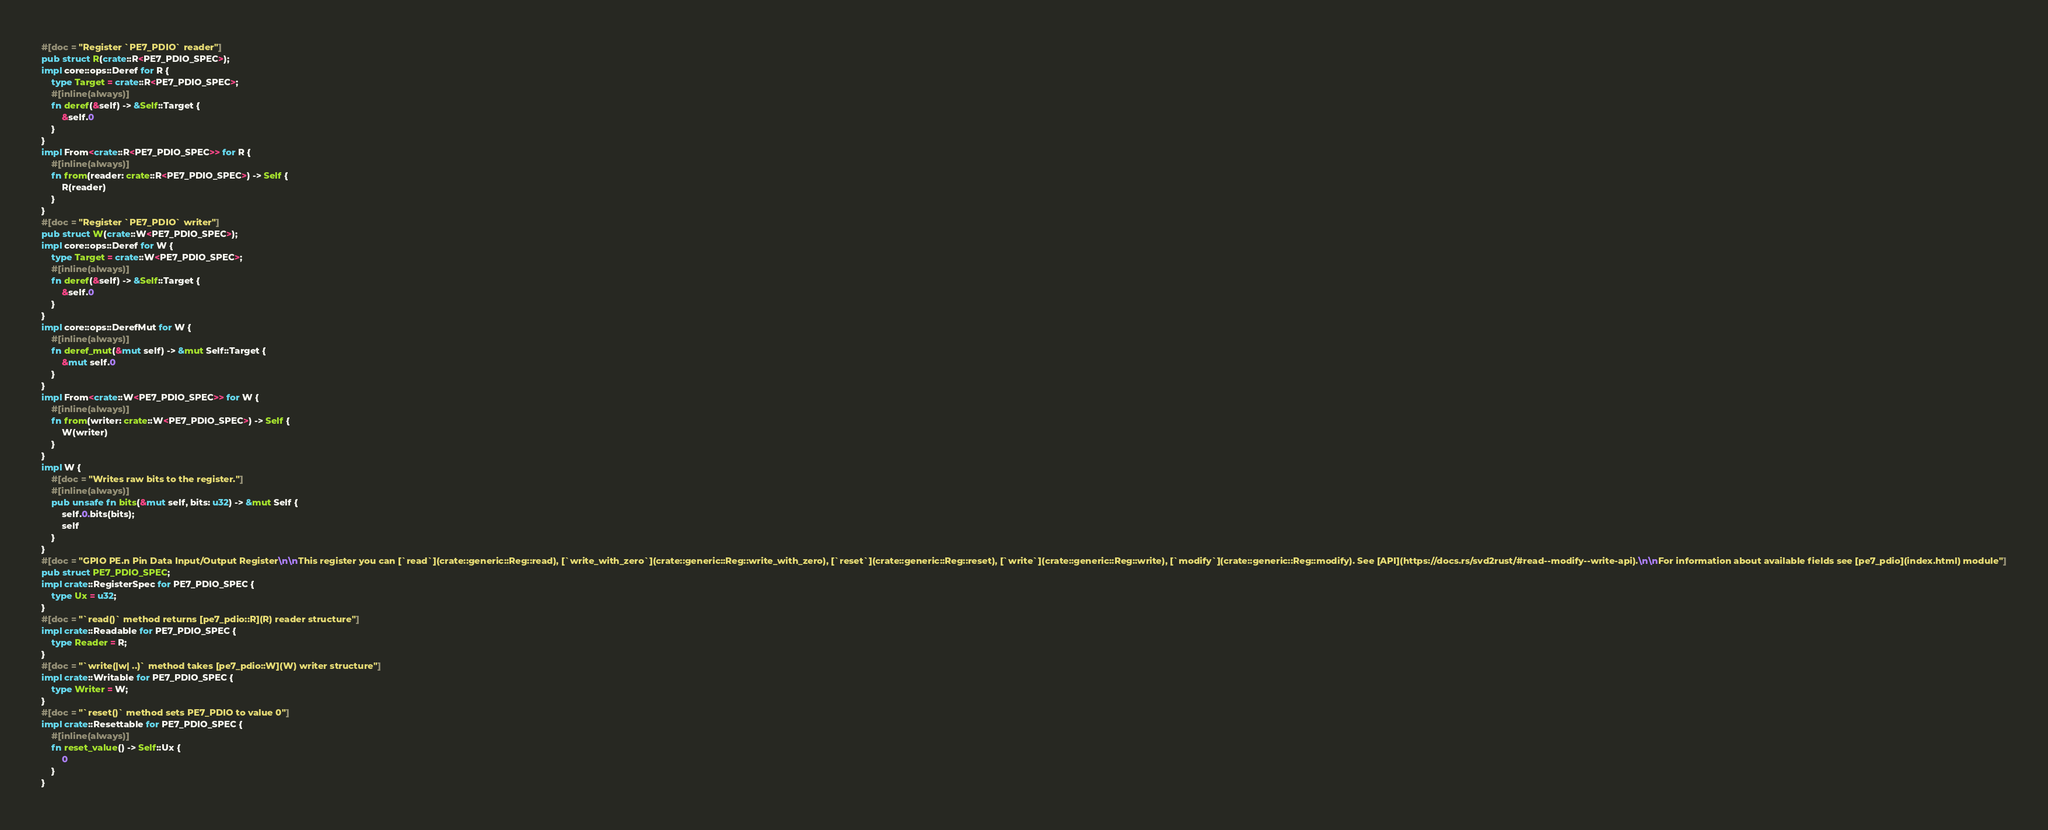Convert code to text. <code><loc_0><loc_0><loc_500><loc_500><_Rust_>#[doc = "Register `PE7_PDIO` reader"]
pub struct R(crate::R<PE7_PDIO_SPEC>);
impl core::ops::Deref for R {
    type Target = crate::R<PE7_PDIO_SPEC>;
    #[inline(always)]
    fn deref(&self) -> &Self::Target {
        &self.0
    }
}
impl From<crate::R<PE7_PDIO_SPEC>> for R {
    #[inline(always)]
    fn from(reader: crate::R<PE7_PDIO_SPEC>) -> Self {
        R(reader)
    }
}
#[doc = "Register `PE7_PDIO` writer"]
pub struct W(crate::W<PE7_PDIO_SPEC>);
impl core::ops::Deref for W {
    type Target = crate::W<PE7_PDIO_SPEC>;
    #[inline(always)]
    fn deref(&self) -> &Self::Target {
        &self.0
    }
}
impl core::ops::DerefMut for W {
    #[inline(always)]
    fn deref_mut(&mut self) -> &mut Self::Target {
        &mut self.0
    }
}
impl From<crate::W<PE7_PDIO_SPEC>> for W {
    #[inline(always)]
    fn from(writer: crate::W<PE7_PDIO_SPEC>) -> Self {
        W(writer)
    }
}
impl W {
    #[doc = "Writes raw bits to the register."]
    #[inline(always)]
    pub unsafe fn bits(&mut self, bits: u32) -> &mut Self {
        self.0.bits(bits);
        self
    }
}
#[doc = "GPIO PE.n Pin Data Input/Output Register\n\nThis register you can [`read`](crate::generic::Reg::read), [`write_with_zero`](crate::generic::Reg::write_with_zero), [`reset`](crate::generic::Reg::reset), [`write`](crate::generic::Reg::write), [`modify`](crate::generic::Reg::modify). See [API](https://docs.rs/svd2rust/#read--modify--write-api).\n\nFor information about available fields see [pe7_pdio](index.html) module"]
pub struct PE7_PDIO_SPEC;
impl crate::RegisterSpec for PE7_PDIO_SPEC {
    type Ux = u32;
}
#[doc = "`read()` method returns [pe7_pdio::R](R) reader structure"]
impl crate::Readable for PE7_PDIO_SPEC {
    type Reader = R;
}
#[doc = "`write(|w| ..)` method takes [pe7_pdio::W](W) writer structure"]
impl crate::Writable for PE7_PDIO_SPEC {
    type Writer = W;
}
#[doc = "`reset()` method sets PE7_PDIO to value 0"]
impl crate::Resettable for PE7_PDIO_SPEC {
    #[inline(always)]
    fn reset_value() -> Self::Ux {
        0
    }
}
</code> 